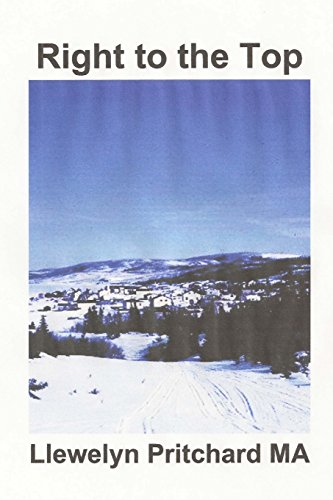Is this book related to Teen & Young Adult? Yes, this book falls under the 'Teen & Young Adult' category, indicating thematic elements likely targeting this demographic. 